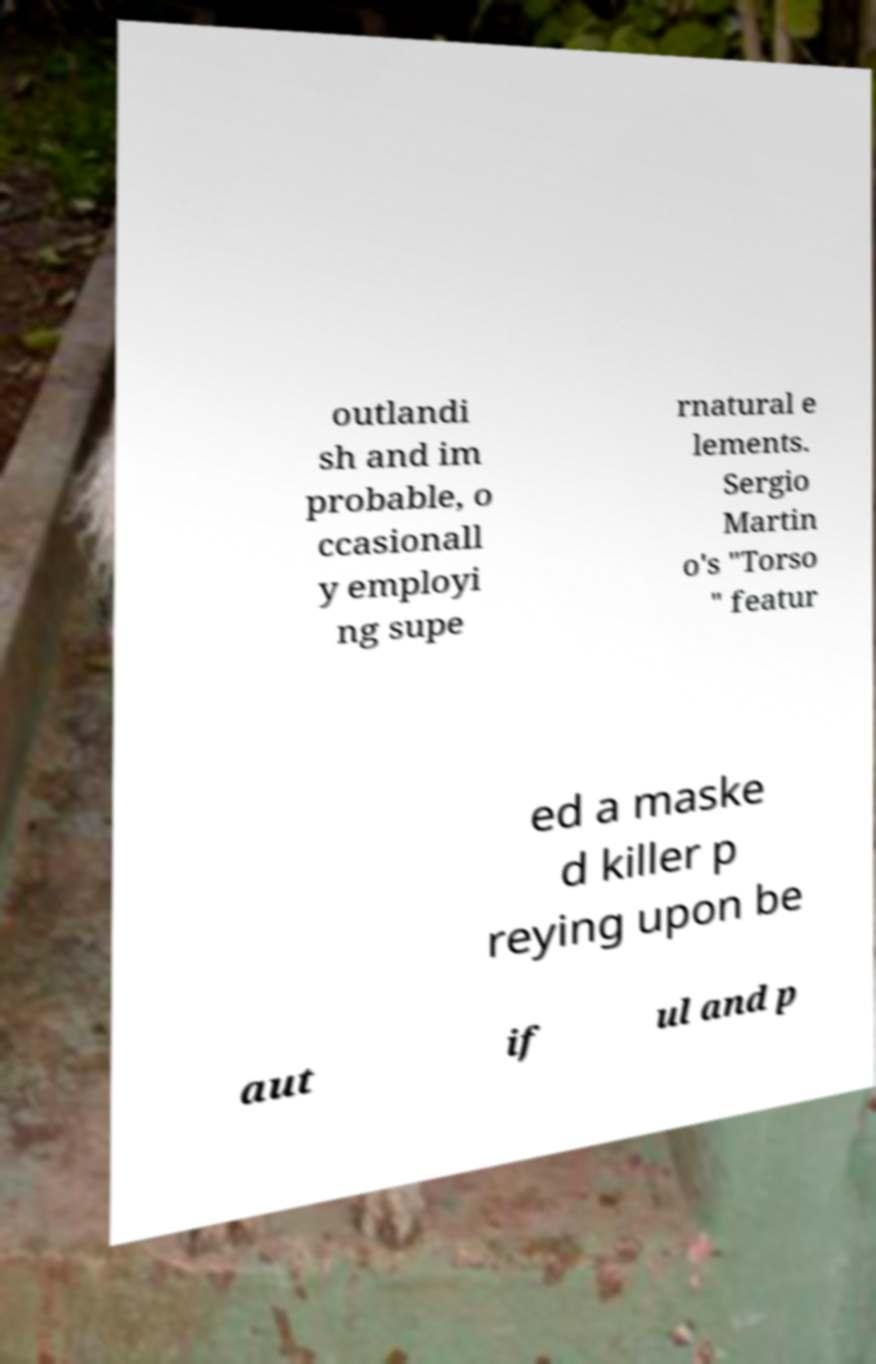What messages or text are displayed in this image? I need them in a readable, typed format. outlandi sh and im probable, o ccasionall y employi ng supe rnatural e lements. Sergio Martin o's "Torso " featur ed a maske d killer p reying upon be aut if ul and p 